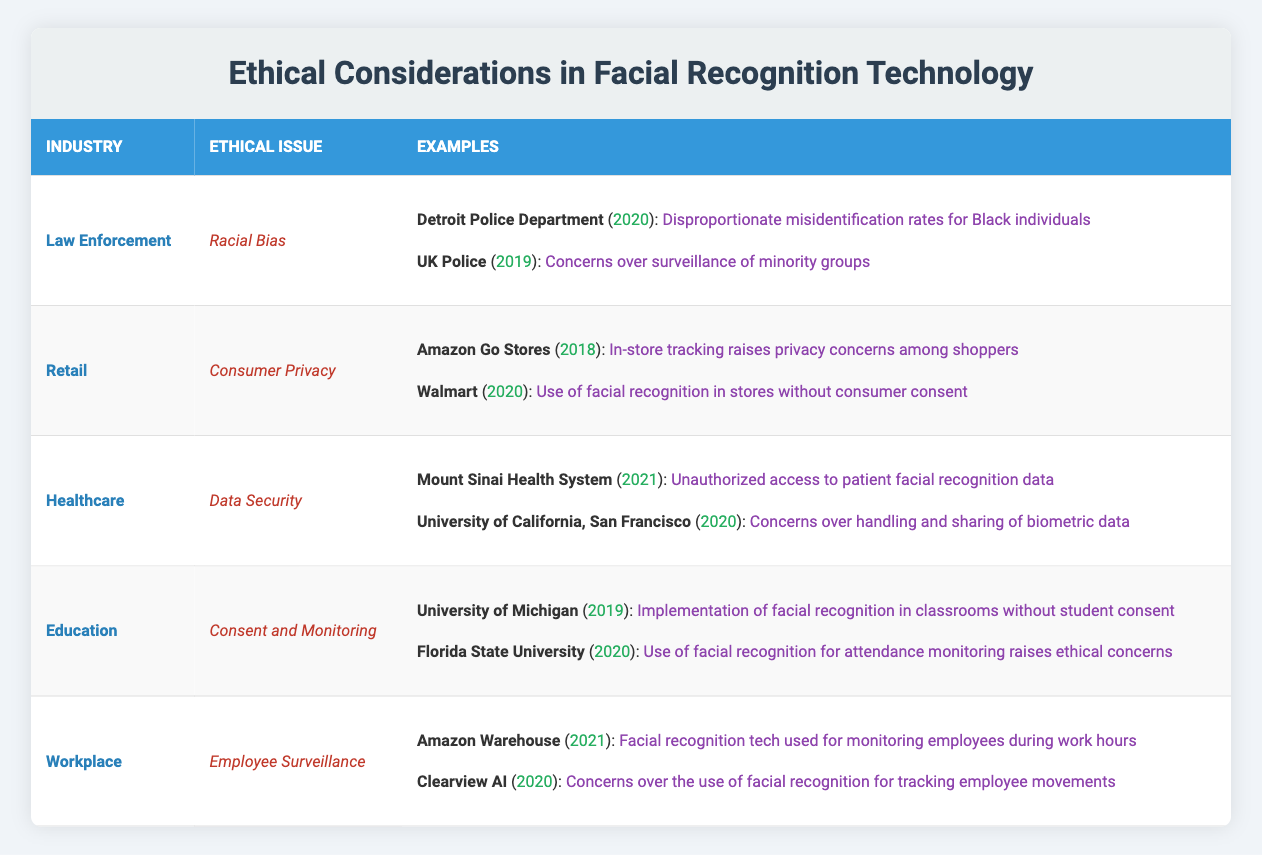What ethical issue is associated with facial recognition technology in law enforcement? The table indicates that the ethical issue related to facial recognition in law enforcement is "Racial Bias".
Answer: Racial Bias Which company used facial recognition technology in stores without consumer consent, according to the retail industry section? The table shows that Walmart used facial recognition in stores without consumer consent, specifically in 2020.
Answer: Walmart In which year did the University of Michigan implement facial recognition in classrooms without student consent? The information provided in the table states that the implementation at the University of Michigan occurred in 2019.
Answer: 2019 How many industries are mentioned in the table? The table lists five industries: Law Enforcement, Retail, Healthcare, Education, and Workplace, totaling five distinct industries.
Answer: 5 Is unauthorized access to patient facial recognition data a concern in the healthcare industry? The table confirms that Mount Sinai Health System faced unauthorized access to patient facial recognition data, indicating that it is indeed a concern.
Answer: Yes What is the impact of facial recognition technology on employee surveillance in workplaces? The table illustrates that concerns include monitoring employees during work hours at Amazon Warehouse and tracking movements via Clearview AI, indicating a significant impact.
Answer: Monitoring during work hours and tracking movements Which industry has the most recent year of ethical issues listed, and what is the issue? Reviewing the table, the most recent ethical issue listed is in the Workplace industry with the case of Amazon Warehouse in 2021, regarding employee surveillance.
Answer: Workplace, Employee Surveillance What are the examples of ethical issues in retail concerning consumer privacy? The table outlines that the examples include Amazon Go Stores in 2018 and Walmart in 2020, both regarding consumer privacy concerns related to facial recognition technology.
Answer: Amazon Go Stores and Walmart From the examples given, which industry had cases in both 2019 and 2020 mentioning ethical issues? The Education industry had cases from both years, as seen with the University of Michigan in 2019 and Florida State University in 2020 addressing consent and monitoring issues.
Answer: Education industry 